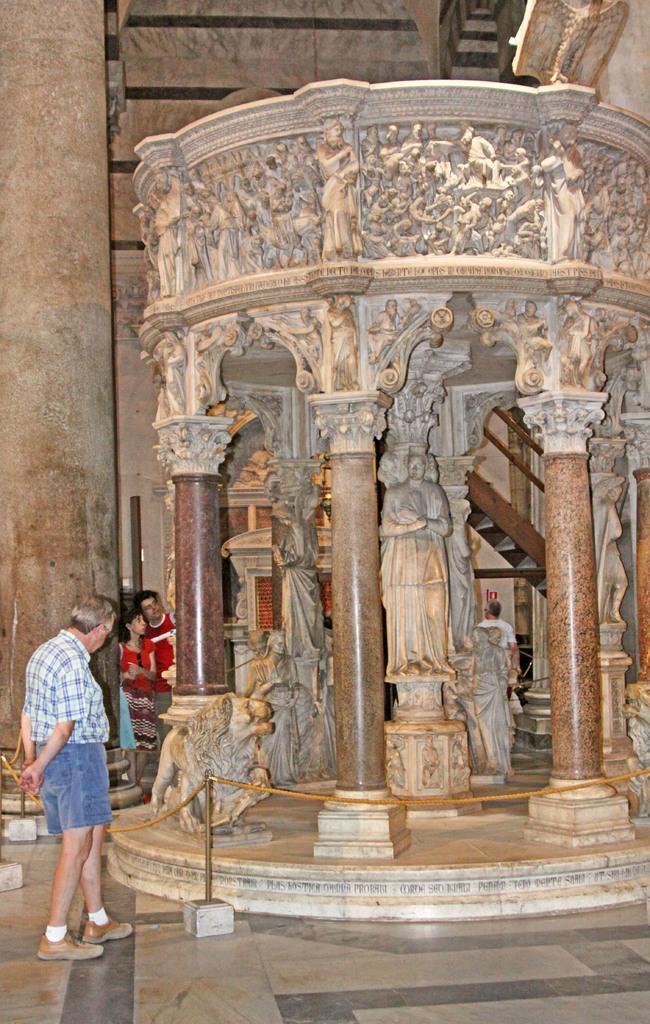Describe this image in one or two sentences. In this image we can see persons standing on the floor, barrier poles, statues, sculptures, staircase, railings and pillars. 